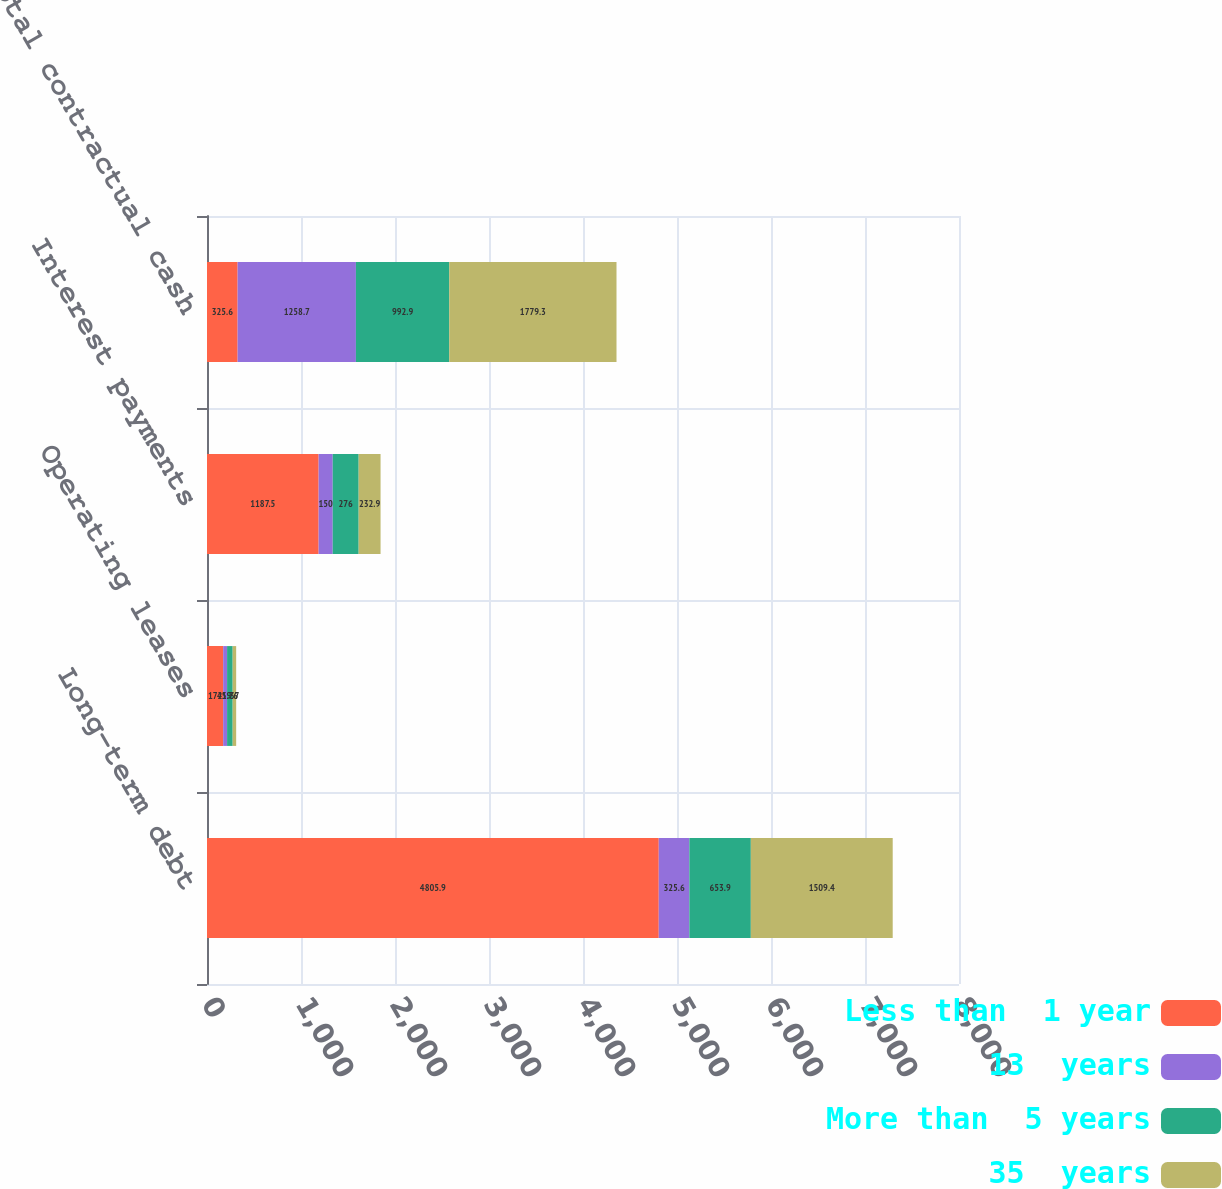Convert chart to OTSL. <chart><loc_0><loc_0><loc_500><loc_500><stacked_bar_chart><ecel><fcel>Long-term debt<fcel>Operating leases<fcel>Interest payments<fcel>Total contractual cash<nl><fcel>Less than  1 year<fcel>4805.9<fcel>172<fcel>1187.5<fcel>325.6<nl><fcel>13  years<fcel>325.6<fcel>41.7<fcel>150<fcel>1258.7<nl><fcel>More than  5 years<fcel>653.9<fcel>59.6<fcel>276<fcel>992.9<nl><fcel>35  years<fcel>1509.4<fcel>37<fcel>232.9<fcel>1779.3<nl></chart> 